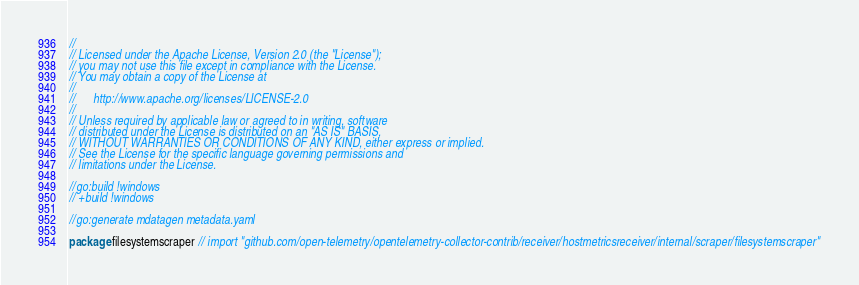Convert code to text. <code><loc_0><loc_0><loc_500><loc_500><_Go_>//
// Licensed under the Apache License, Version 2.0 (the "License");
// you may not use this file except in compliance with the License.
// You may obtain a copy of the License at
//
//      http://www.apache.org/licenses/LICENSE-2.0
//
// Unless required by applicable law or agreed to in writing, software
// distributed under the License is distributed on an "AS IS" BASIS,
// WITHOUT WARRANTIES OR CONDITIONS OF ANY KIND, either express or implied.
// See the License for the specific language governing permissions and
// limitations under the License.

//go:build !windows
// +build !windows

//go:generate mdatagen metadata.yaml

package filesystemscraper // import "github.com/open-telemetry/opentelemetry-collector-contrib/receiver/hostmetricsreceiver/internal/scraper/filesystemscraper"
</code> 